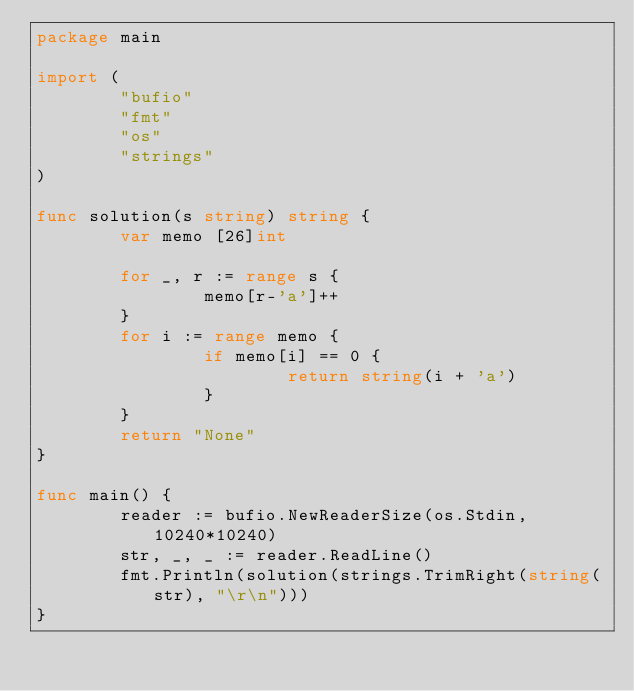Convert code to text. <code><loc_0><loc_0><loc_500><loc_500><_Go_>package main

import (
        "bufio"
        "fmt"
        "os"
        "strings"
)

func solution(s string) string {
        var memo [26]int

        for _, r := range s {
                memo[r-'a']++
        }
        for i := range memo {
                if memo[i] == 0 {
                        return string(i + 'a')
                }
        }
        return "None"
}

func main() {
        reader := bufio.NewReaderSize(os.Stdin, 10240*10240)
        str, _, _ := reader.ReadLine()
        fmt.Println(solution(strings.TrimRight(string(str), "\r\n")))
}</code> 